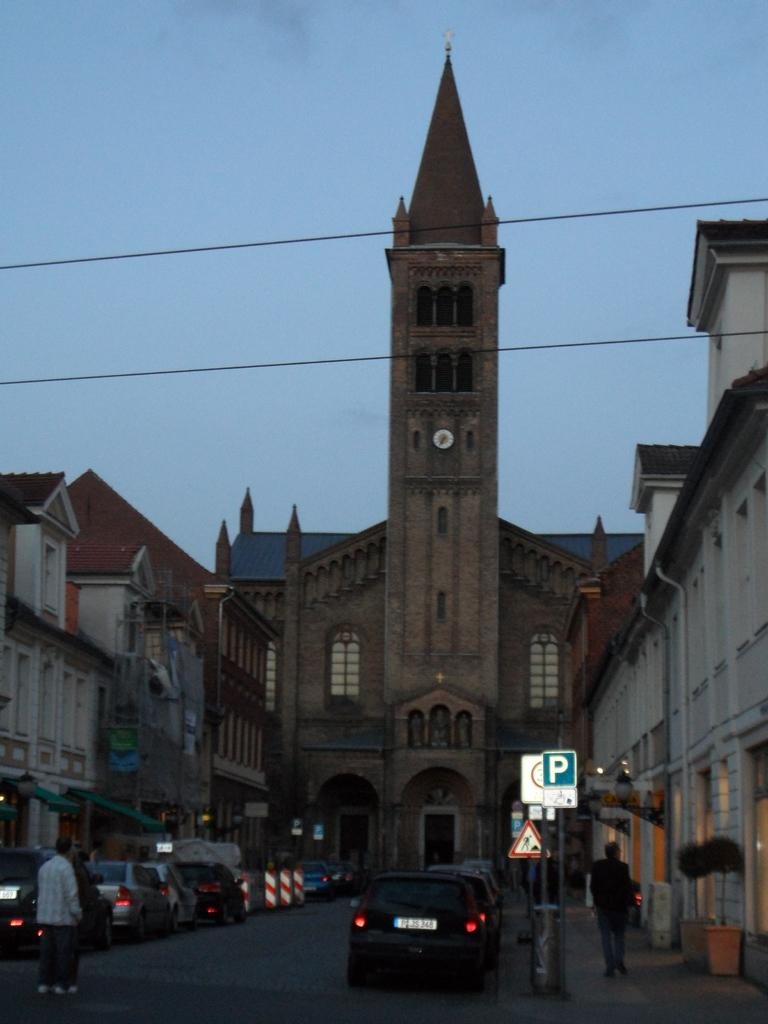What is the person in the image doing? The person is walking in the image. Where is the person walking? The person is standing on the road while walking. What else can be seen in the image besides the person? There are vehicles, boards on poles, buildings, wires, and the sky visible in the image. Can you see a ghost playing with the vehicles in the image? No, there is no ghost or any indication of play in the image. The image only shows a person walking on the road, vehicles, boards on poles, buildings, wires, and the sky. 